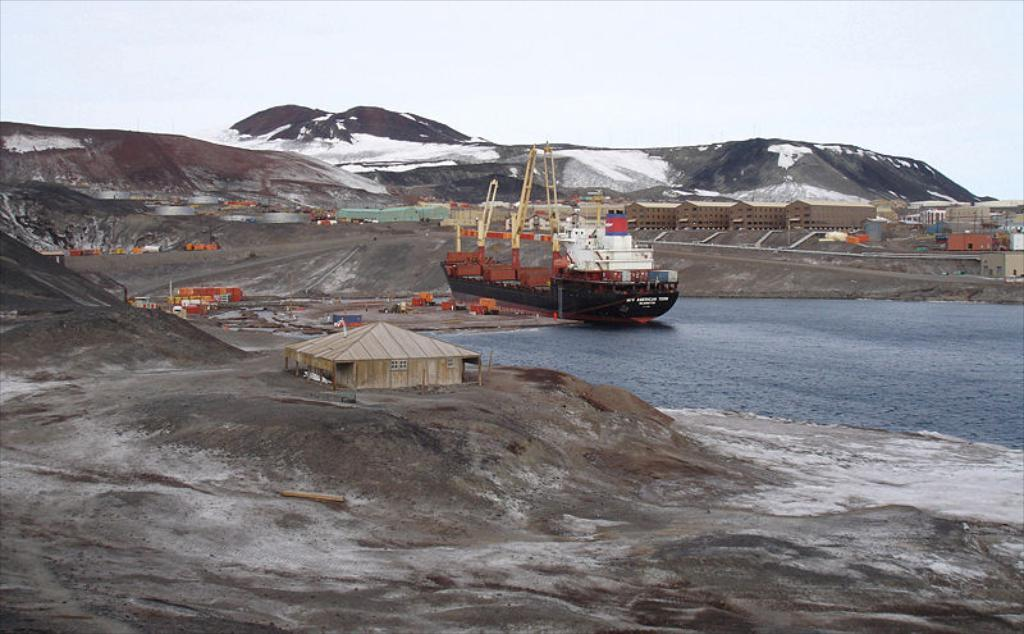What type of boat is at the dock in the image? There is a container boat at the dock in the image. What is in front of the boat? There is water in front of the boat. What can be seen around the boat? There are buildings and container boxes around the boat. What is visible in the background of the image? There are mountains visible in the image. What language is the farmer speaking to the boat in the image? There is no farmer present in the image, and therefore no language can be associated with the boat. 